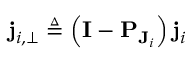Convert formula to latex. <formula><loc_0><loc_0><loc_500><loc_500>j _ { i , \perp } \triangle q \left ( I - P _ { J _ { i } } \right ) j _ { i }</formula> 